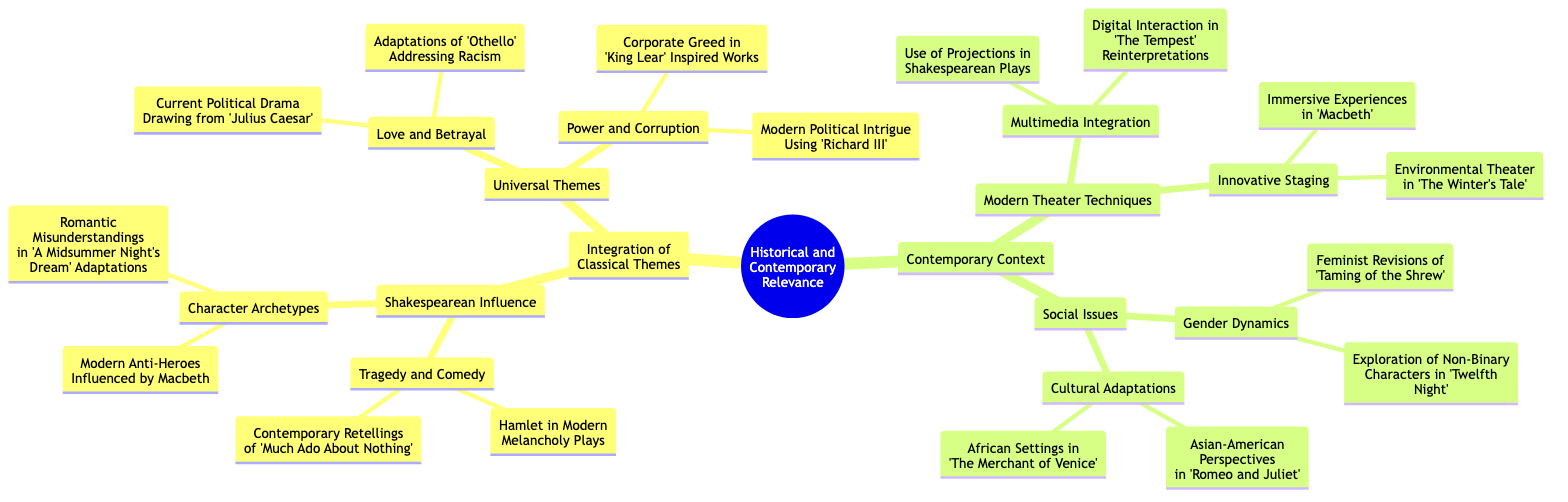What is the main topic of the mind map? The main topic, represented at the root of the diagram, is "Historical and Contemporary Relevance." This phrase is at the top and encompasses all the subtopics and themes explored in the diagram.
Answer: Historical and Contemporary Relevance How many main branches are there from the root? The root contains two main branches: "Integration of Classical Themes" and "Contemporary Context." Counting these branches gives a total of 2.
Answer: 2 What are the two subcategories under Shakespearean Influence? The subcategories under Shakespearean Influence are "Tragedy and Comedy" and "Character Archetypes." These are distinct themes that explore different aspects of Shakespeare's influence.
Answer: Tragedy and Comedy, Character Archetypes Which universal theme relates to "Corporate Greed"? The theme "Corporate Greed" is associated with "Power and Corruption." This indicates that corporate greed is viewed through the lens of issues concerning power dynamics and moral corruption in society.
Answer: Power and Corruption What modern technique is used in "The Tempest" reinterpretations? The technique mentioned is "Digital Interaction." This indicates a contemporary approach to staging that incorporates technology to enhance the audience's experience during the performance.
Answer: Digital Interaction Which play’s modern adaptations address racism? The adaptations that address racism draw from "Othello." This connection highlights how themes of discrimination and race remain relevant in contemporary interpretations of the play.
Answer: Othello How many key social issues are identified in the mind map? The mind map identifies two main social issues: "Gender Dynamics" and "Cultural Adaptations." These represent significant contemporary concerns that are reflected in modern reinterpretations of classical plays.
Answer: 2 What character archetype is influenced by Macbeth? The archetype influenced by Macbeth is "Modern Anti-Heroes." This indicates a connection between the themes found in Macbeth and the characteristics of current protagonists in modern storytelling.
Answer: Modern Anti-Heroes What type of theater technique emphasizes immersion in "Macbeth"? The technique emphasizing immersion is "Immersive Experiences." This suggests that modern adaptations of Macbeth may utilize methods that fully engage the audience in the narrative.
Answer: Immersive Experiences 